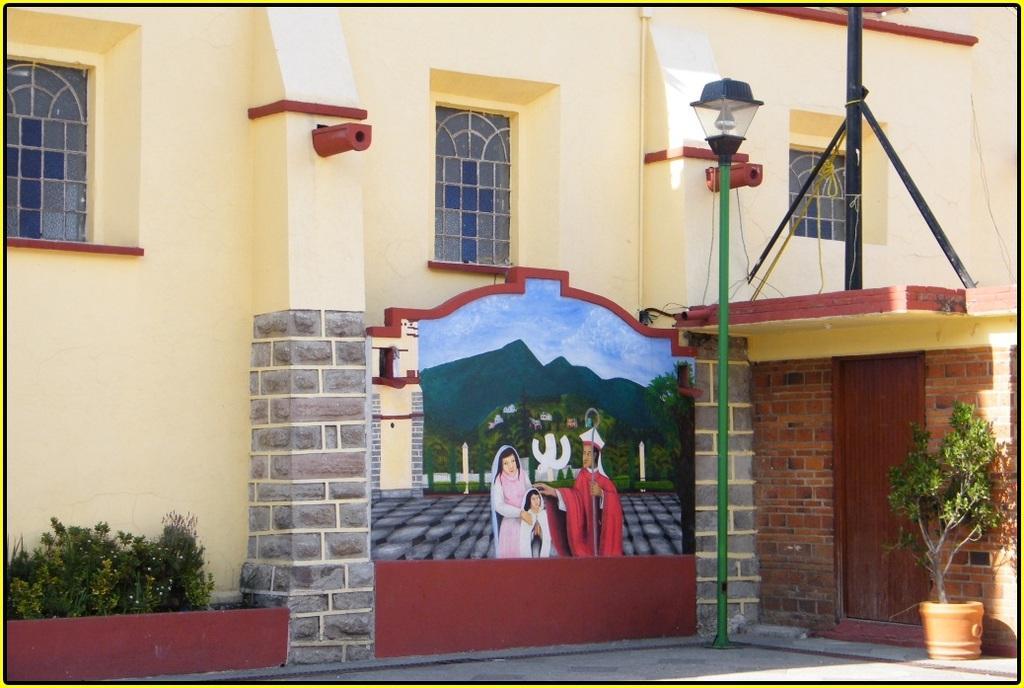Please provide a concise description of this image. In the picture there is a building and there is a painting in front of the building, on the right side there is a pole light, beside that there is a door and in front of the door there is a plant. 